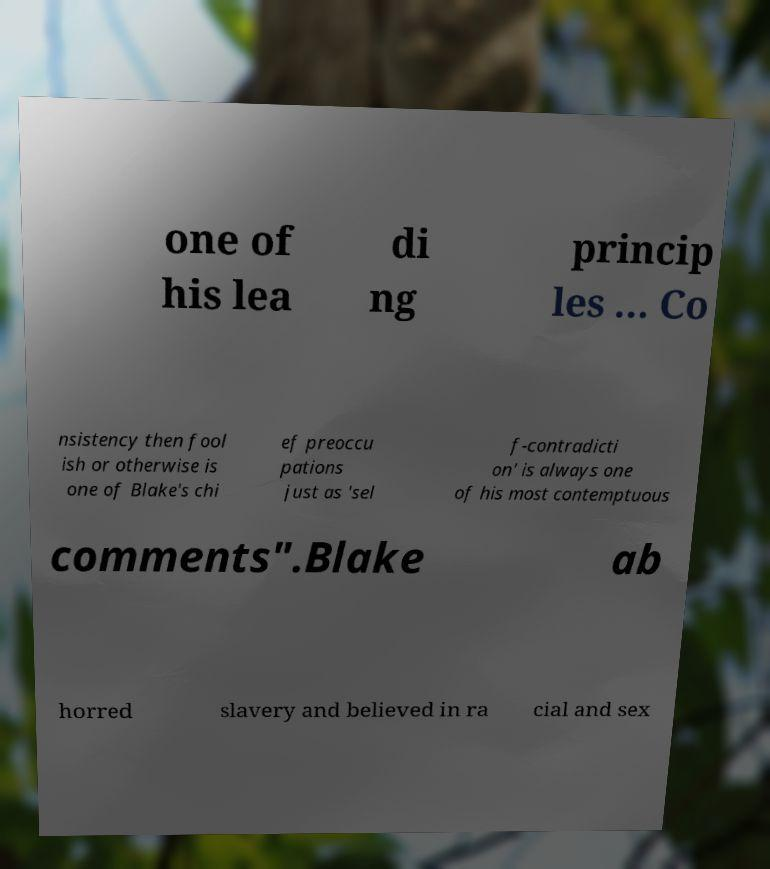Please identify and transcribe the text found in this image. one of his lea di ng princip les ... Co nsistency then fool ish or otherwise is one of Blake's chi ef preoccu pations just as 'sel f-contradicti on' is always one of his most contemptuous comments".Blake ab horred slavery and believed in ra cial and sex 